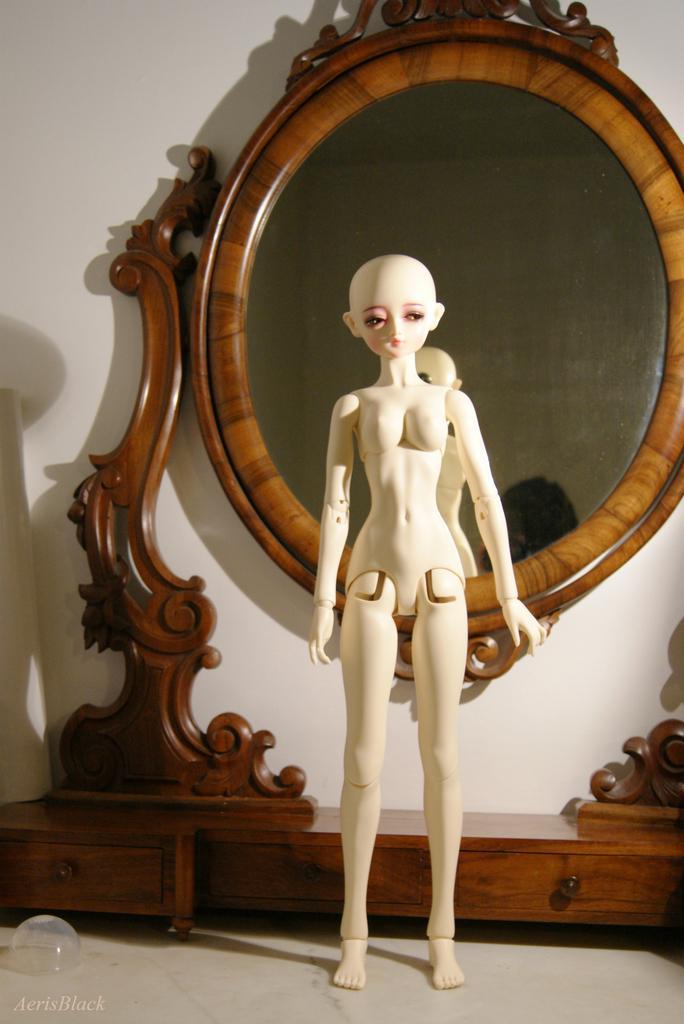Please provide a concise description of this image. In this picture I can see a doll standing, there is a mirror with drawers, there is an object, and in the background there is a wall and there is a watermark on the image. 